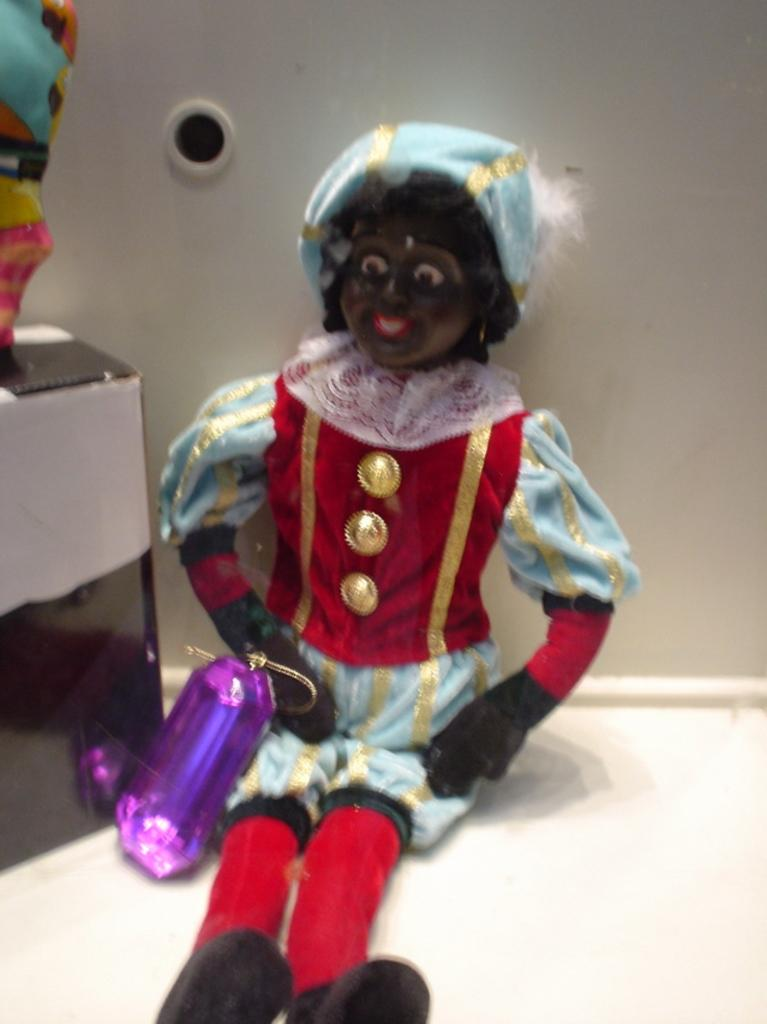What is the main subject of the image? There is a toy on a white surface in the image. What can be seen on the left side of the image? There are objects on the left side of the image. What is visible in the background of the image? There is a wall in the background of the image. What type of vacation is being enjoyed by the toy in the image? There is no indication of a vacation in the image, as it features a toy on a white surface with objects on the left side and a wall in the background. Is there any smoke visible in the image? No, there is no smoke present in the image. 